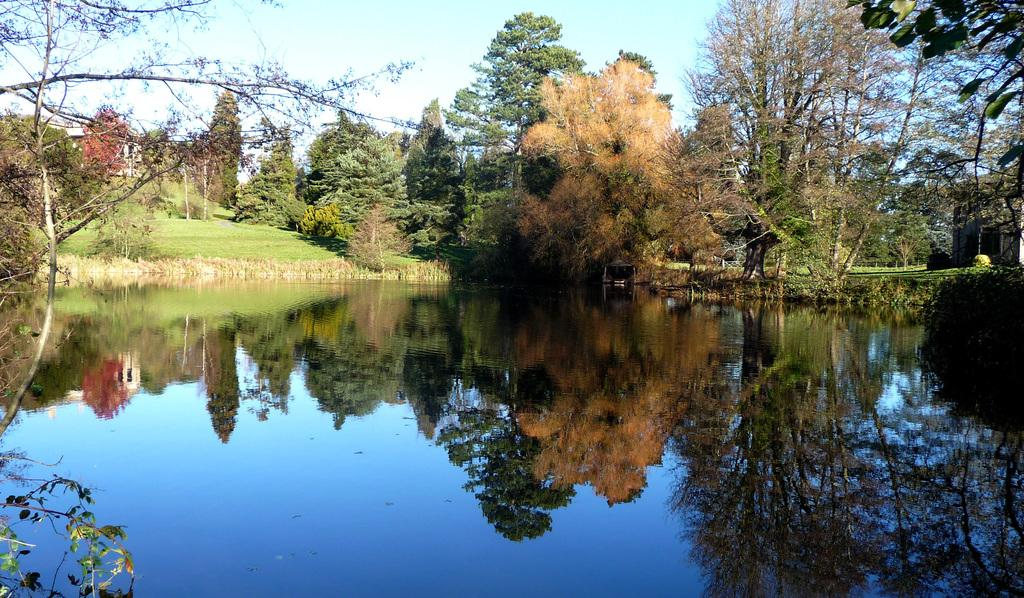What is the primary element in the image? There is water in the image. What type of vegetation can be seen in the image? There are trees in the image. What colors are present on the trees? The trees have green, brown, and red colors. What type of structure is visible in the image? There is a house in the image. What is visible in the background of the image? The sky is visible in the background of the image. Who is the creator of the pin that can be seen in the image? There is no pin present in the image. Is the image taken during winter, given the presence of trees with red colors? The facts provided do not mention the season or weather conditions, so it cannot be determined if the image was taken during winter based on the colors of the trees. 